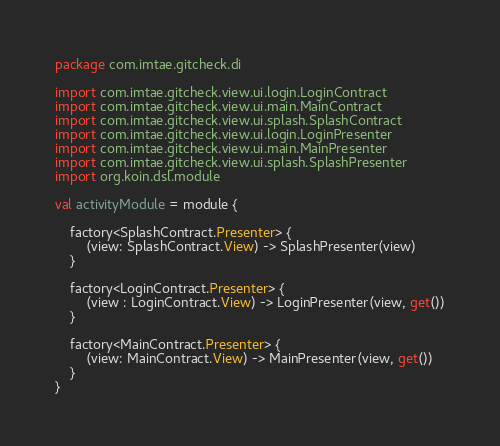Convert code to text. <code><loc_0><loc_0><loc_500><loc_500><_Kotlin_>package com.imtae.gitcheck.di

import com.imtae.gitcheck.view.ui.login.LoginContract
import com.imtae.gitcheck.view.ui.main.MainContract
import com.imtae.gitcheck.view.ui.splash.SplashContract
import com.imtae.gitcheck.view.ui.login.LoginPresenter
import com.imtae.gitcheck.view.ui.main.MainPresenter
import com.imtae.gitcheck.view.ui.splash.SplashPresenter
import org.koin.dsl.module

val activityModule = module {

    factory<SplashContract.Presenter> {
        (view: SplashContract.View) -> SplashPresenter(view)
    }

    factory<LoginContract.Presenter> {
        (view : LoginContract.View) -> LoginPresenter(view, get())
    }

    factory<MainContract.Presenter> {
        (view: MainContract.View) -> MainPresenter(view, get())
    }
}</code> 